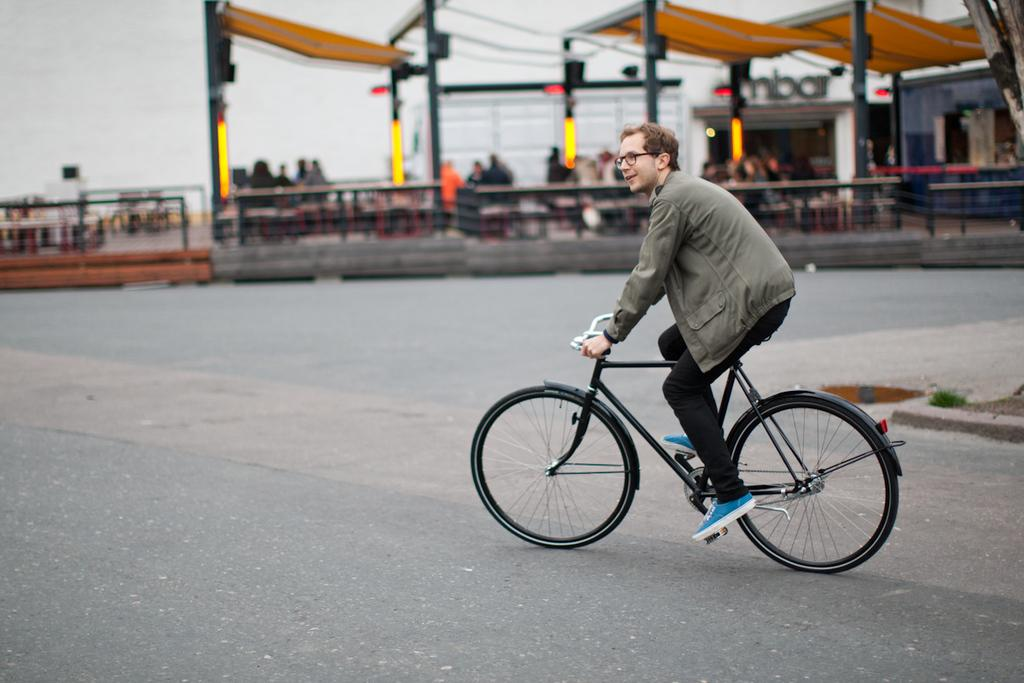What is the man in the image doing? The man is riding a bicycle in the image. Can you describe the people in the image? There are people seated in the image. What type of mist can be seen surrounding the field in the image? There is no mist or field present in the image; it features a man riding a bicycle and people seated. 